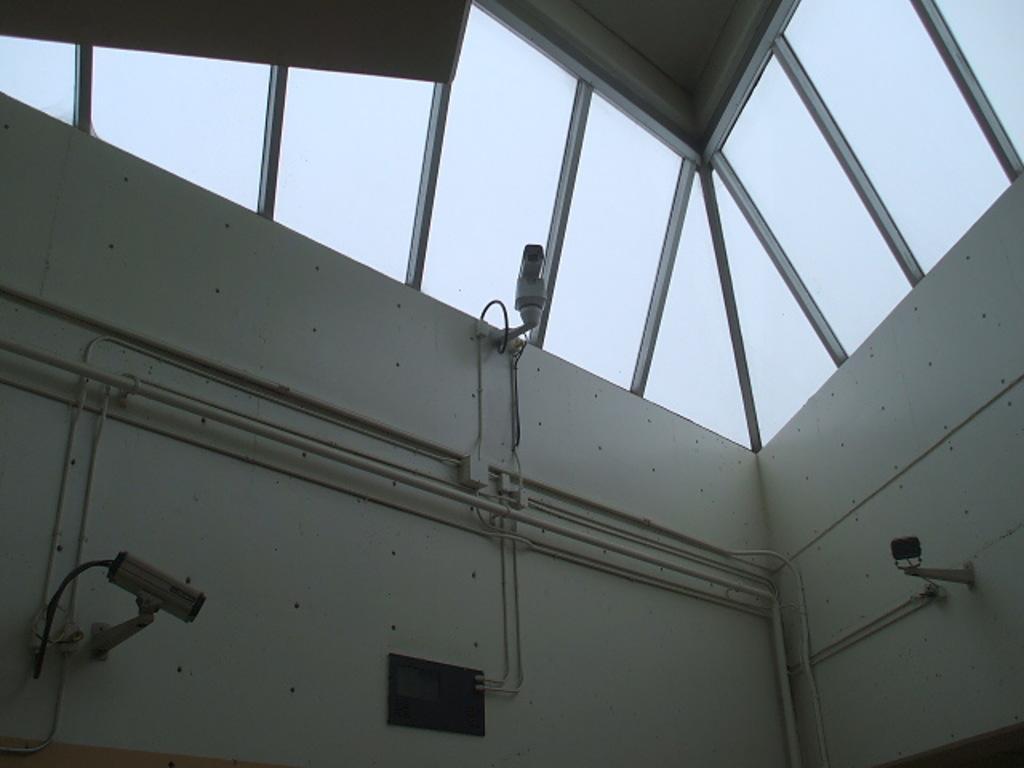Could you give a brief overview of what you see in this image? In this image we can see white color walls and glass windows. The CCTV cameras are present. 